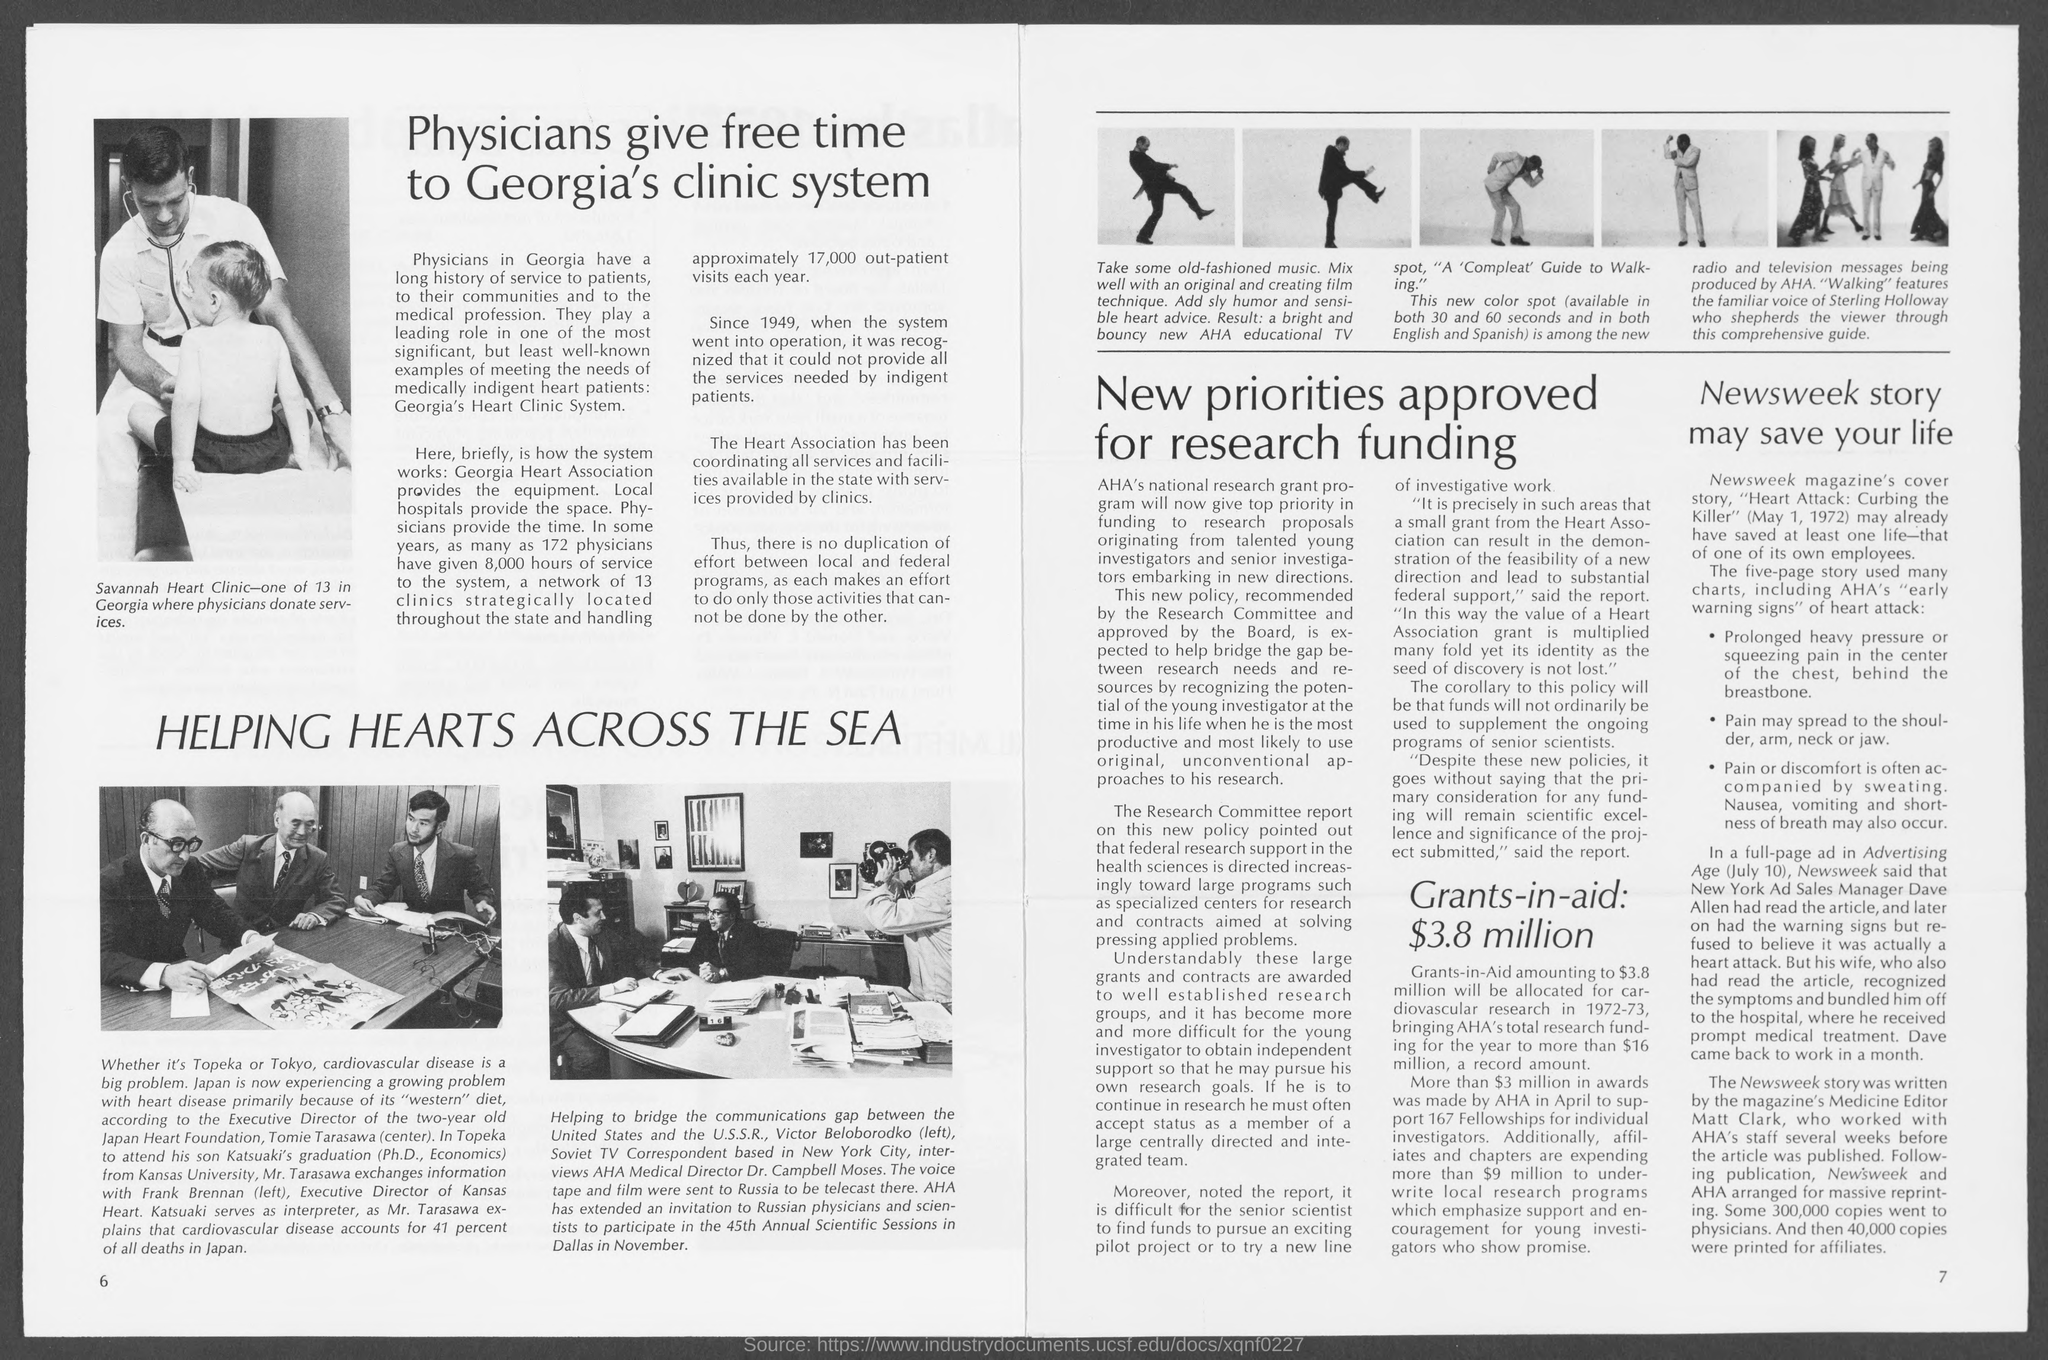Outline some significant characteristics in this image. The voice that is featured in "Walking" belongs to Sterling Holloway. The name of Tomie Tarasawa's son is Katsuaki. The person who wrote the Newsweek story about medicine is named Sterling Holloway. Eight thousand hours of service have been provided by 172 physicians to the system. Kansas Heart's executive director is Frank Brennan. 